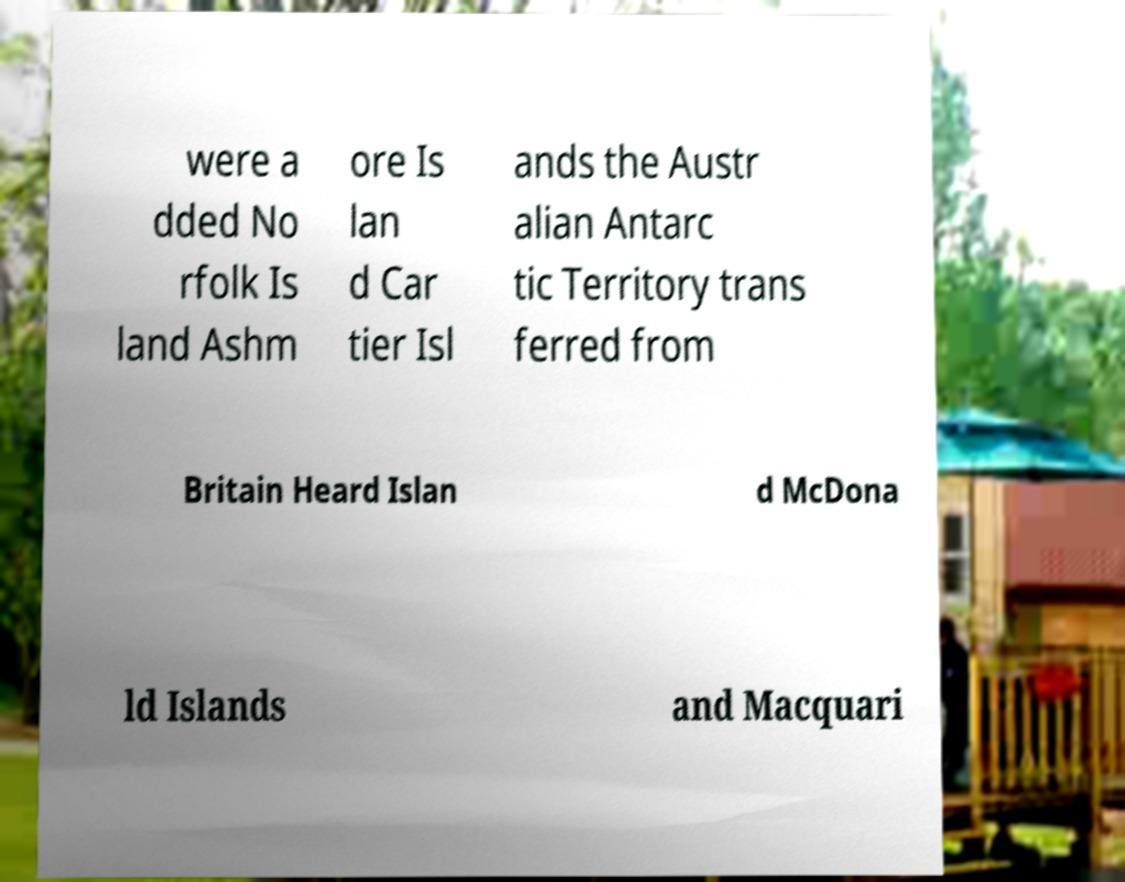Can you read and provide the text displayed in the image?This photo seems to have some interesting text. Can you extract and type it out for me? were a dded No rfolk Is land Ashm ore Is lan d Car tier Isl ands the Austr alian Antarc tic Territory trans ferred from Britain Heard Islan d McDona ld Islands and Macquari 